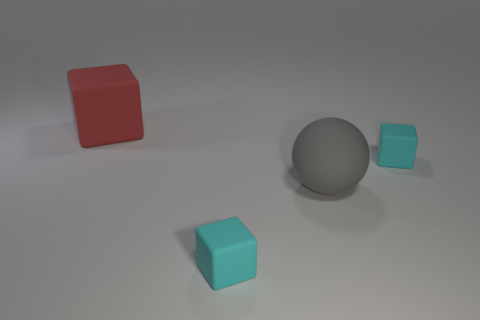The large sphere is what color?
Make the answer very short. Gray. What number of other big gray rubber objects are the same shape as the gray object?
Keep it short and to the point. 0. What number of things are tiny red metal cylinders or large rubber things that are in front of the red object?
Offer a very short reply. 1. There is a sphere; is it the same color as the tiny matte thing that is behind the large gray thing?
Your answer should be compact. No. What is the size of the matte thing that is on the left side of the big gray matte object and behind the big gray matte ball?
Provide a succinct answer. Large. There is a gray matte sphere; are there any matte things to the right of it?
Provide a succinct answer. Yes. Are there any large rubber objects behind the cyan matte block that is behind the large ball?
Your answer should be very brief. Yes. Are there the same number of matte objects that are in front of the big matte block and gray rubber things in front of the large gray rubber ball?
Make the answer very short. No. There is a big object that is made of the same material as the sphere; what color is it?
Provide a succinct answer. Red. Is there a small cyan object that has the same material as the red object?
Give a very brief answer. Yes. 